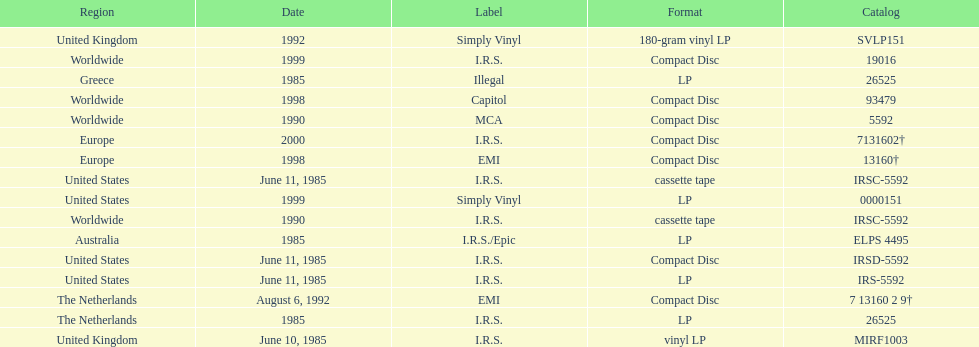In how many countries was the album released before 1990? 5. 